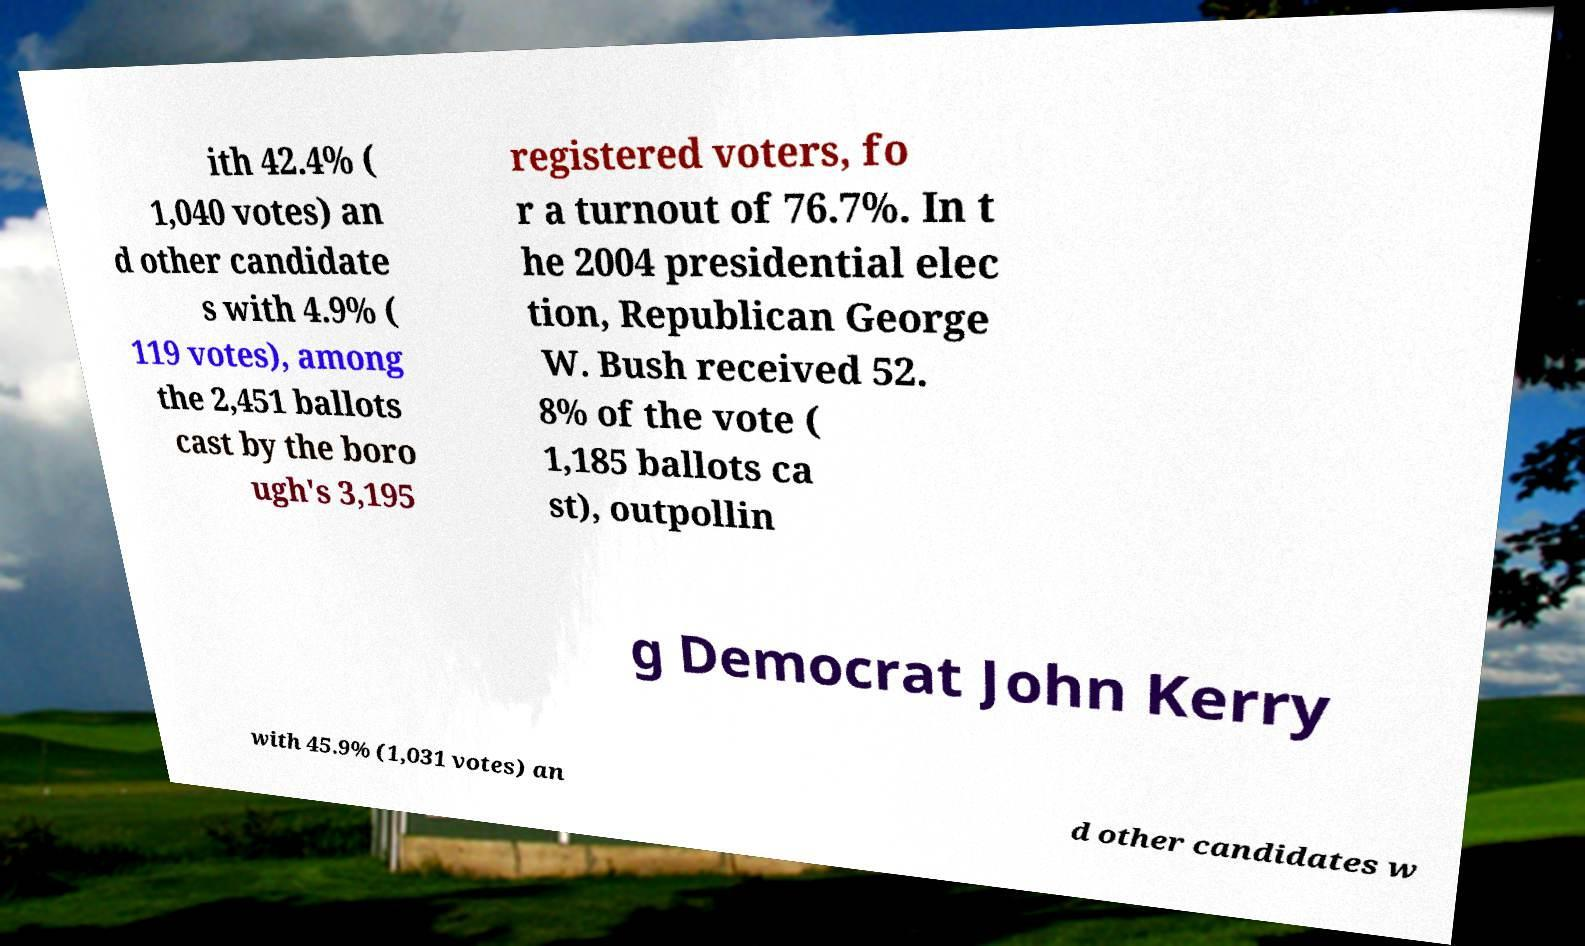Could you assist in decoding the text presented in this image and type it out clearly? ith 42.4% ( 1,040 votes) an d other candidate s with 4.9% ( 119 votes), among the 2,451 ballots cast by the boro ugh's 3,195 registered voters, fo r a turnout of 76.7%. In t he 2004 presidential elec tion, Republican George W. Bush received 52. 8% of the vote ( 1,185 ballots ca st), outpollin g Democrat John Kerry with 45.9% (1,031 votes) an d other candidates w 